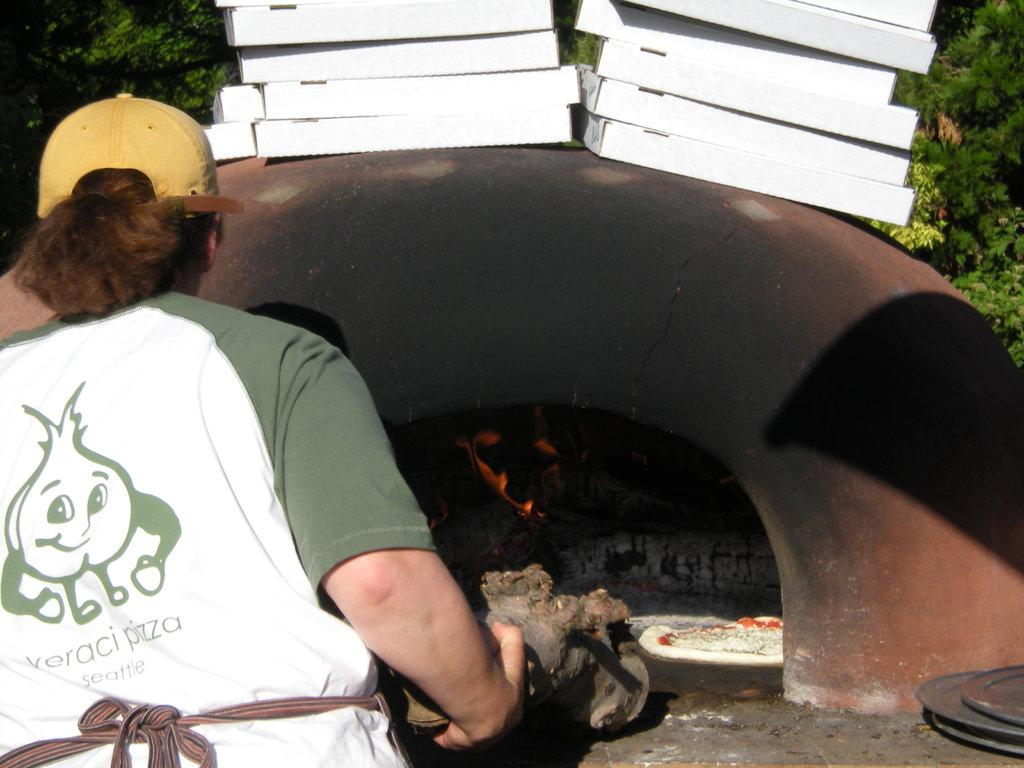<image>
Relay a brief, clear account of the picture shown. A guy wearing a pizza shirt is baking a pizza. 